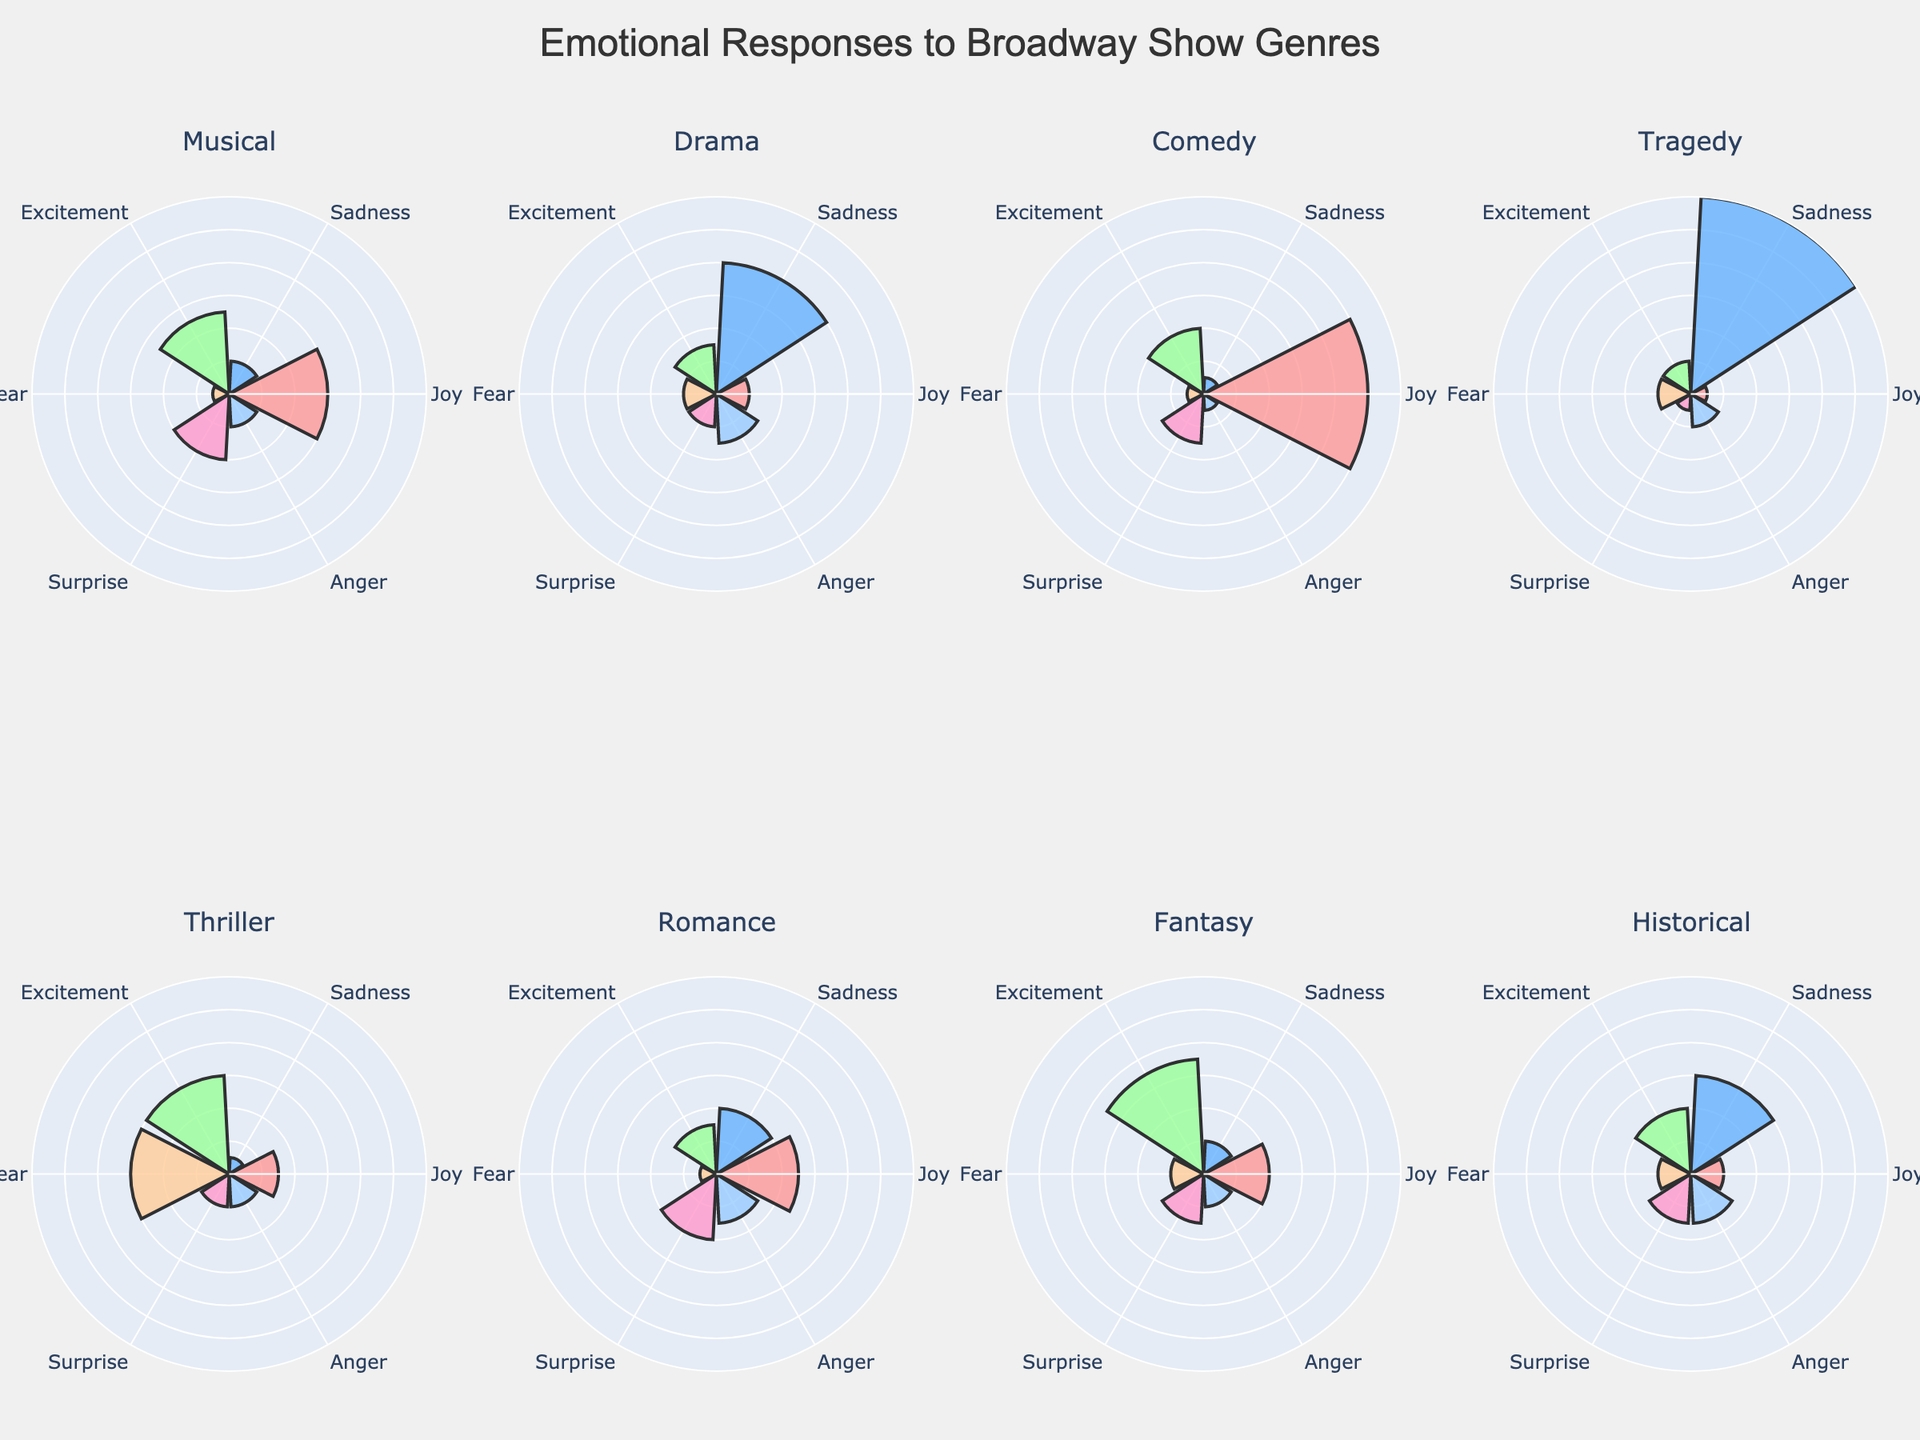what genre has the highest percentage of joy? To find this, look at the "Joy" percentage in each subplot and identify the highest value. Comedy has the highest percentage of joy at 50%.
Answer: Comedy what's the sum of percentages for sadness and anger in drama? Look at the "Drama" subplot and find the percentages for sadness and anger. They are 40% and 15%, respectively. Sum these values: 40 + 15 = 55%.
Answer: 55% which genre has a higher percentage of fear: tragedy or thriller? Compare the "Fear" percentages for Tragedy and Thriller. Tragedy shows 10%, whereas Thriller shows 30%. Thriller has a higher percentage of fear.
Answer: Thriller which genre has an equal percentage of joy and sadness? Identify which subplot shows the same percentage for both joy and sadness. Romance shows 25% for both joy and sadness.
Answer: Romance in which genre does excitement have the highest percentage? Identify the "Excitement" percentages across all subplots and find the highest. Fantasy has the highest percentage of excitement at 35%.
Answer: Fantasy how does the percentage of surprise compare between musical and historical? Look at the "Surprise" percentages in the Musical and Historical subplots. Musical has 20%, and Historical has 15%, so Musical has a higher percentage of surprise.
Answer: Musical what is the average percentage of sadness across all genres? Add up all the sadness percentages and divide by the number of genres. (10+40+5+60+5+20+10+30) / 8 = 22.5%.
Answer: 22.5% are there any genres where joy and excitement percentages combined exceed 50%? For each genre, sum the percentages of joy and excitement and check if any exceeds 50%. Only Comedy (50% joy + 20% excitement) meets the criterion with 70%.
Answer: Comedy which emotion appears with the highest percentage in tragedy? Look at the "Tragedy" subplot and identify the highest percentage value. Sadness has the highest percentage at 60%.
Answer: Sadness is there any genre with similar percentages for fear and surprise? Look at each genre and compare the percentages of fear and surprise. Thriller and Historical both show 30% fear and 30% or lower in surprise, but Thriller is the closest with both percentages at 30% fear and 10% surprise, respectively.
Answer: Thriller 